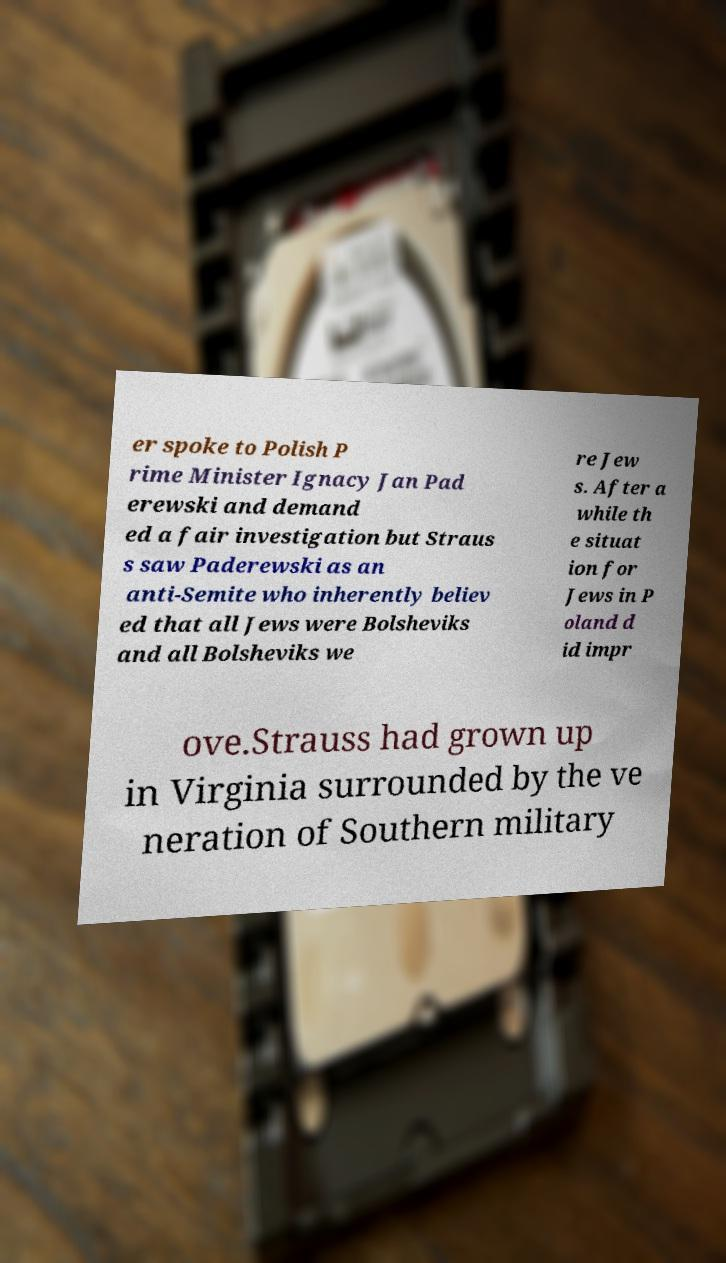Can you read and provide the text displayed in the image?This photo seems to have some interesting text. Can you extract and type it out for me? er spoke to Polish P rime Minister Ignacy Jan Pad erewski and demand ed a fair investigation but Straus s saw Paderewski as an anti-Semite who inherently believ ed that all Jews were Bolsheviks and all Bolsheviks we re Jew s. After a while th e situat ion for Jews in P oland d id impr ove.Strauss had grown up in Virginia surrounded by the ve neration of Southern military 